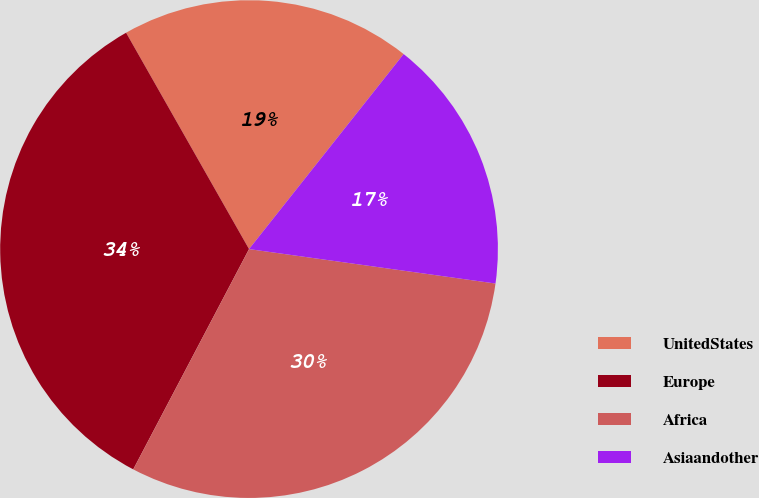<chart> <loc_0><loc_0><loc_500><loc_500><pie_chart><fcel>UnitedStates<fcel>Europe<fcel>Africa<fcel>Asiaandother<nl><fcel>18.89%<fcel>34.07%<fcel>30.49%<fcel>16.54%<nl></chart> 